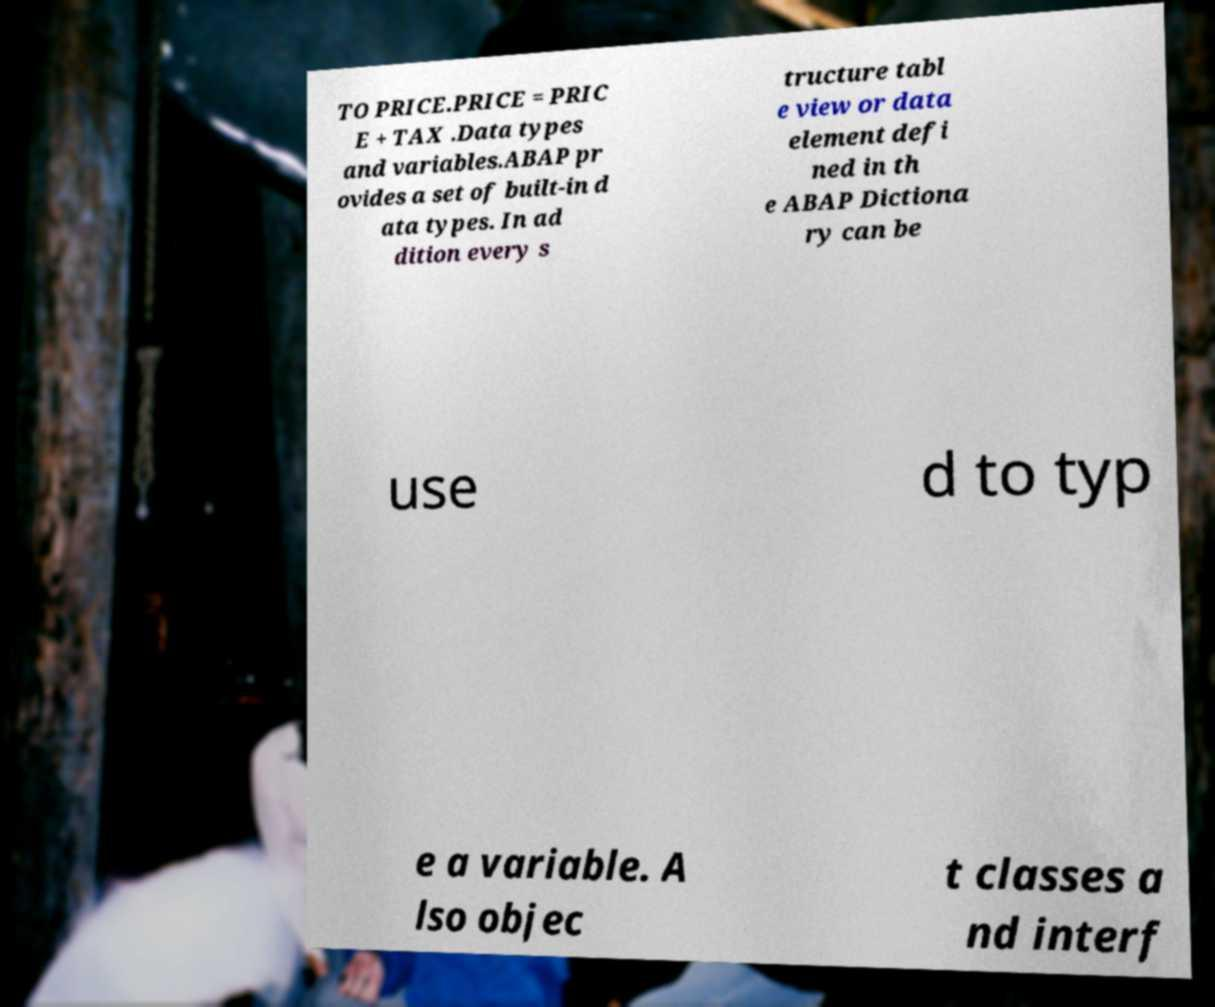Please identify and transcribe the text found in this image. TO PRICE.PRICE = PRIC E + TAX .Data types and variables.ABAP pr ovides a set of built-in d ata types. In ad dition every s tructure tabl e view or data element defi ned in th e ABAP Dictiona ry can be use d to typ e a variable. A lso objec t classes a nd interf 